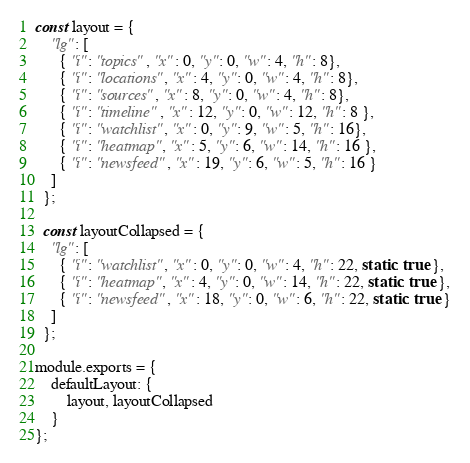<code> <loc_0><loc_0><loc_500><loc_500><_JavaScript_>const layout = {
    "lg": [
      { "i": "topics", "x": 0, "y": 0, "w": 4, "h": 8},
      { "i": "locations", "x": 4, "y": 0, "w": 4, "h": 8},
      { "i": "sources", "x": 8, "y": 0, "w": 4, "h": 8},
      { "i": "timeline", "x": 12, "y": 0, "w": 12, "h": 8 },
      { "i": "watchlist", "x": 0, "y": 9, "w": 5, "h": 16},
      { "i": "heatmap", "x": 5, "y": 6, "w": 14, "h": 16 },
      { "i": "newsfeed", "x": 19, "y": 6, "w": 5, "h": 16 }
    ]
  };
  
  const layoutCollapsed = {
    "lg": [
      { "i": "watchlist", "x": 0, "y": 0, "w": 4, "h": 22, static: true },
      { "i": "heatmap", "x": 4, "y": 0, "w": 14, "h": 22, static: true },
      { "i": "newsfeed", "x": 18, "y": 0, "w": 6, "h": 22, static: true }
    ]
  };

module.exports = {
    defaultLayout: {
        layout, layoutCollapsed
    }
};</code> 